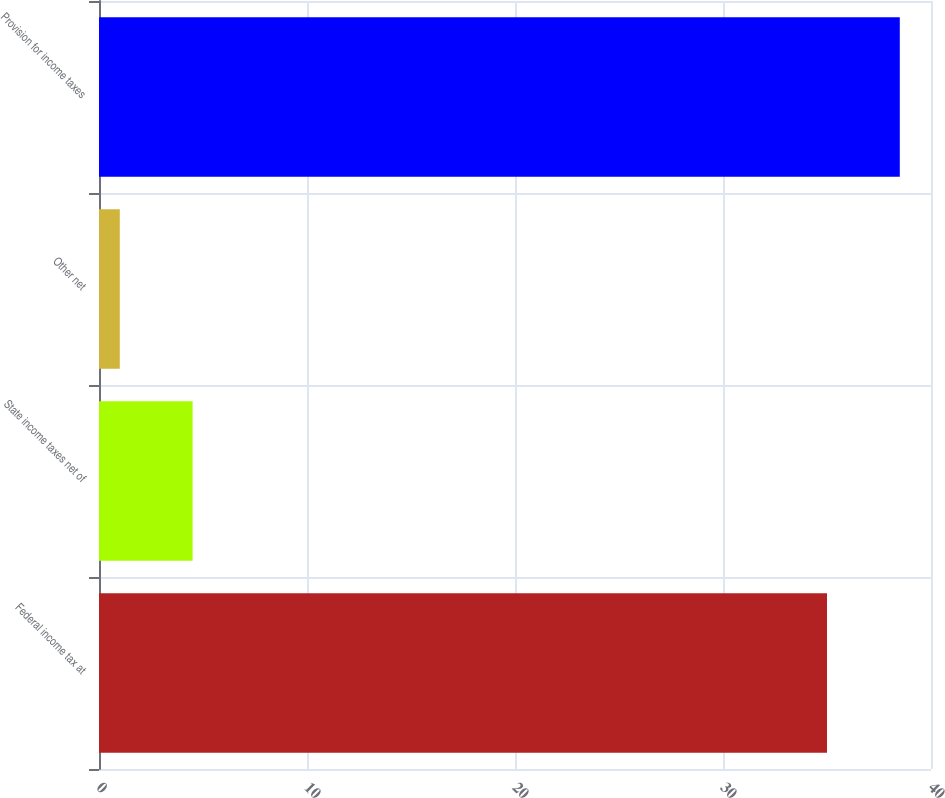Convert chart to OTSL. <chart><loc_0><loc_0><loc_500><loc_500><bar_chart><fcel>Federal income tax at<fcel>State income taxes net of<fcel>Other net<fcel>Provision for income taxes<nl><fcel>35<fcel>4.5<fcel>1<fcel>38.5<nl></chart> 